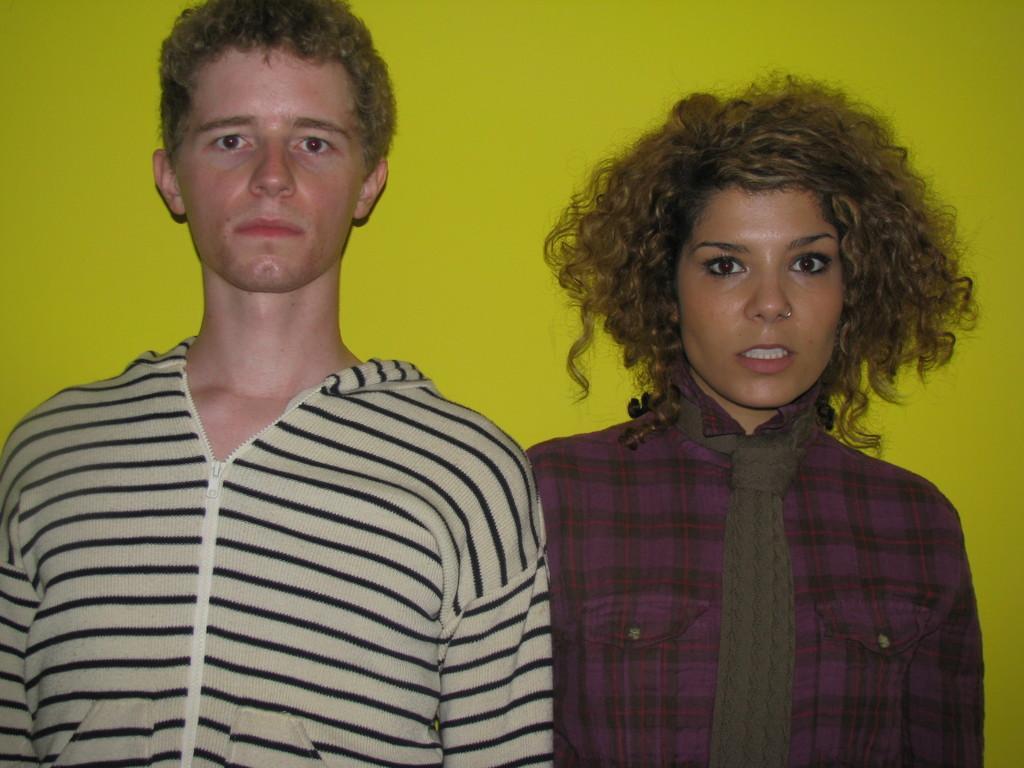Describe this image in one or two sentences. There is a man and a woman. Woman is wearing a scarf. In the background there is a wall. 